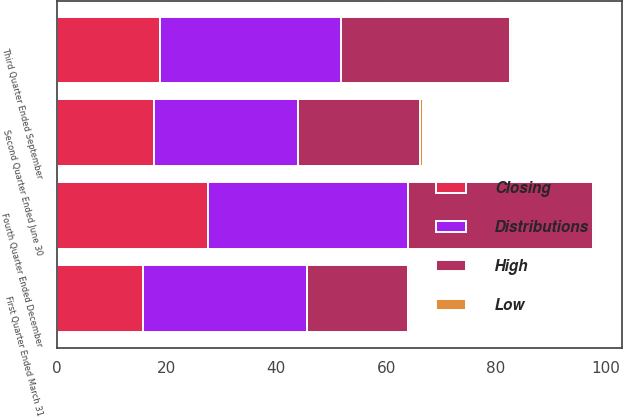Convert chart. <chart><loc_0><loc_0><loc_500><loc_500><stacked_bar_chart><ecel><fcel>Fourth Quarter Ended December<fcel>Third Quarter Ended September<fcel>Second Quarter Ended June 30<fcel>First Quarter Ended March 31<nl><fcel>Distributions<fcel>36.38<fcel>33.06<fcel>26.24<fcel>29.87<nl><fcel>Closing<fcel>27.54<fcel>18.8<fcel>17.73<fcel>15.68<nl><fcel>High<fcel>33.78<fcel>30.7<fcel>22.23<fcel>18.35<nl><fcel>Low<fcel>0.34<fcel>0.34<fcel>0.48<fcel>0.48<nl></chart> 